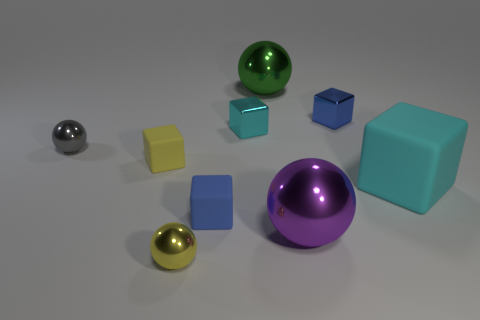Subtract all tiny yellow rubber blocks. How many blocks are left? 4 Subtract all yellow spheres. How many brown blocks are left? 0 Subtract all purple balls. How many balls are left? 3 Subtract all spheres. How many objects are left? 5 Subtract 4 cubes. How many cubes are left? 1 Subtract all purple blocks. Subtract all red spheres. How many blocks are left? 5 Subtract all large purple metallic things. Subtract all big rubber things. How many objects are left? 7 Add 8 yellow things. How many yellow things are left? 10 Add 2 tiny cyan blocks. How many tiny cyan blocks exist? 3 Add 1 red metallic spheres. How many objects exist? 10 